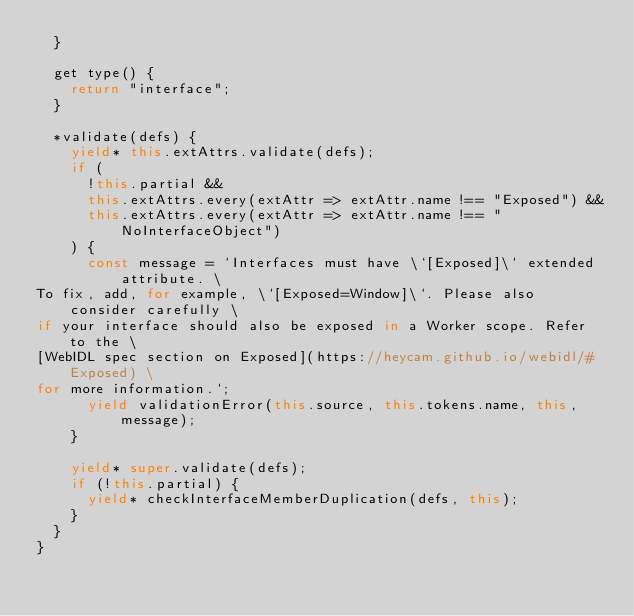Convert code to text. <code><loc_0><loc_0><loc_500><loc_500><_JavaScript_>  }

  get type() {
    return "interface";
  }

  *validate(defs) {
    yield* this.extAttrs.validate(defs);
    if (
      !this.partial &&
      this.extAttrs.every(extAttr => extAttr.name !== "Exposed") &&
      this.extAttrs.every(extAttr => extAttr.name !== "NoInterfaceObject")
    ) {
      const message = `Interfaces must have \`[Exposed]\` extended attribute. \
To fix, add, for example, \`[Exposed=Window]\`. Please also consider carefully \
if your interface should also be exposed in a Worker scope. Refer to the \
[WebIDL spec section on Exposed](https://heycam.github.io/webidl/#Exposed) \
for more information.`;
      yield validationError(this.source, this.tokens.name, this, message);
    }

    yield* super.validate(defs);
    if (!this.partial) {
      yield* checkInterfaceMemberDuplication(defs, this);
    }
  }
}
</code> 